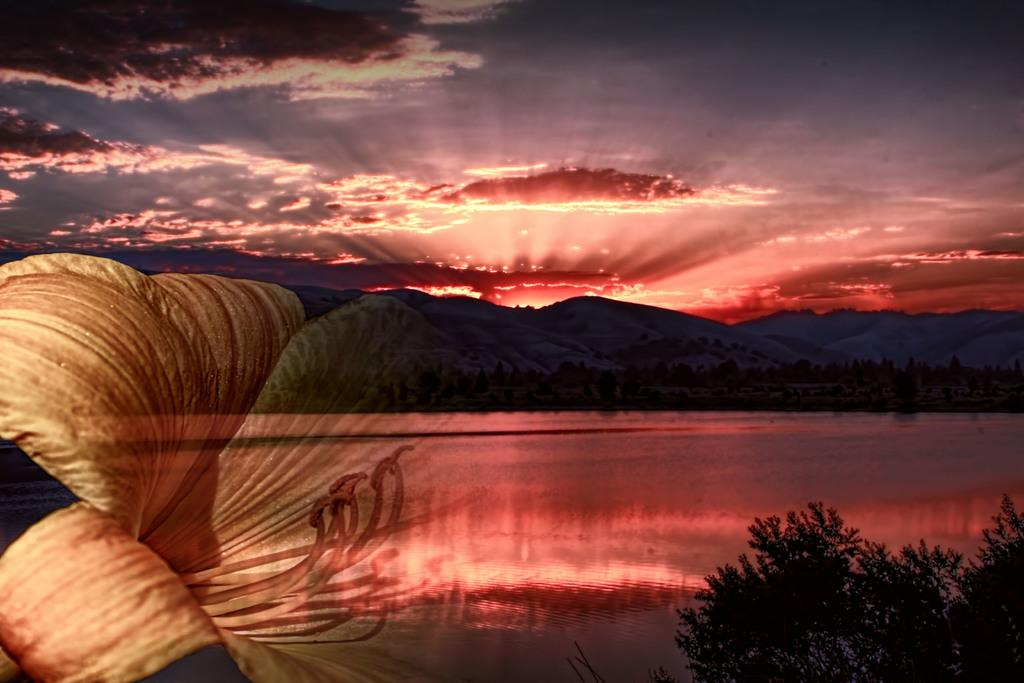What type of vegetation can be seen in the image? There are trees in the image. What geographical features are present in the image? There are hills and water visible in the image. What part of the natural environment is visible in the image? The sky is visible in the image. Can you describe a specific object on the left side of the image? There is a flower on the left side of the image. What type of business is being conducted in the image? There is no indication of any business activity in the image. What scent can be detected from the flower in the image? The image is not capable of conveying scents, so it is impossible to determine the scent of the flower. 